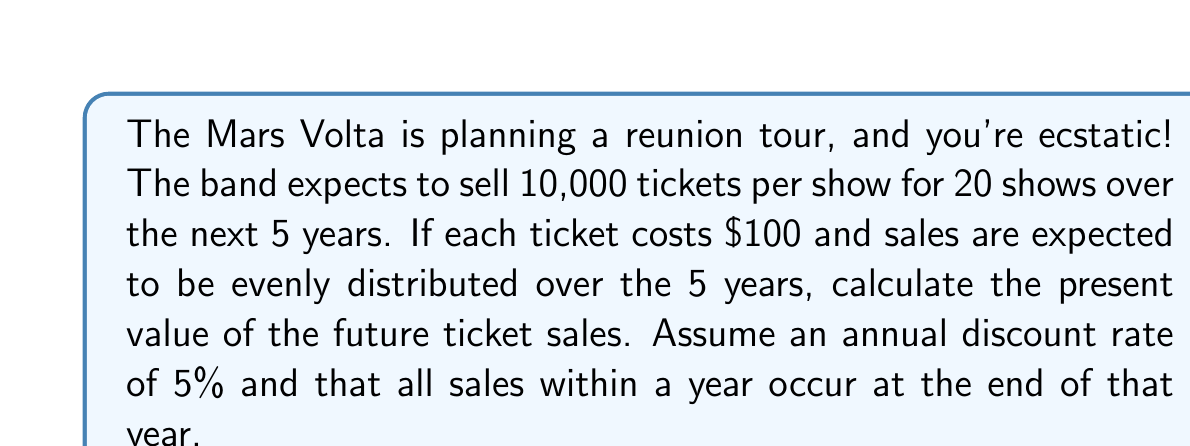Could you help me with this problem? To solve this problem, we need to:
1. Calculate the total revenue per year
2. Determine the cash flow for each year
3. Calculate the present value of each year's cash flow
4. Sum up the present values

Step 1: Calculate total revenue per year
Total tickets = 10,000 tickets/show × 20 shows = 200,000 tickets
Total revenue = 200,000 tickets × $100/ticket = $20,000,000
Revenue per year = $20,000,000 ÷ 5 years = $4,000,000/year

Step 2: Cash flow for each year
Year 1 to 5: $4,000,000 per year

Step 3: Calculate present value for each year
Present Value formula: $PV = \frac{FV}{(1+r)^n}$
Where:
FV = Future Value
r = discount rate
n = number of years

Year 1: $PV_1 = \frac{4,000,000}{(1+0.05)^1} = 3,809,523.81$
Year 2: $PV_2 = \frac{4,000,000}{(1+0.05)^2} = 3,628,117.91$
Year 3: $PV_3 = \frac{4,000,000}{(1+0.05)^3} = 3,455,350.39$
Year 4: $PV_4 = \frac{4,000,000}{(1+0.05)^4} = 3,290,809.90$
Year 5: $PV_5 = \frac{4,000,000}{(1+0.05)^5} = 3,134,104.66$

Step 4: Sum up the present values
Total Present Value = $PV_1 + PV_2 + PV_3 + PV_4 + PV_5$
$= 3,809,523.81 + 3,628,117.91 + 3,455,350.39 + 3,290,809.90 + 3,134,104.66$
$= 17,317,906.67$
Answer: $17,317,906.67 